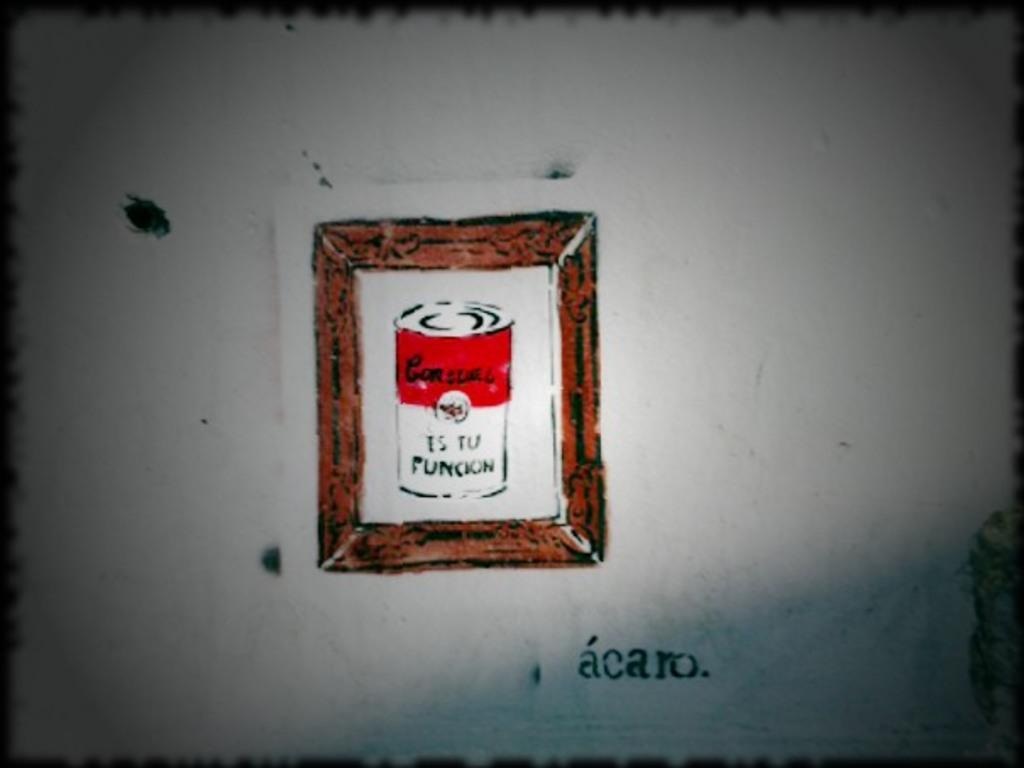What is depicted on the wall in the image? There is a picture painted on the wall in the image. How many worms can be seen crawling on the amusement park ride in the image? There are no worms or amusement park rides present in the image. The image only contains a picture painted on the wall. 